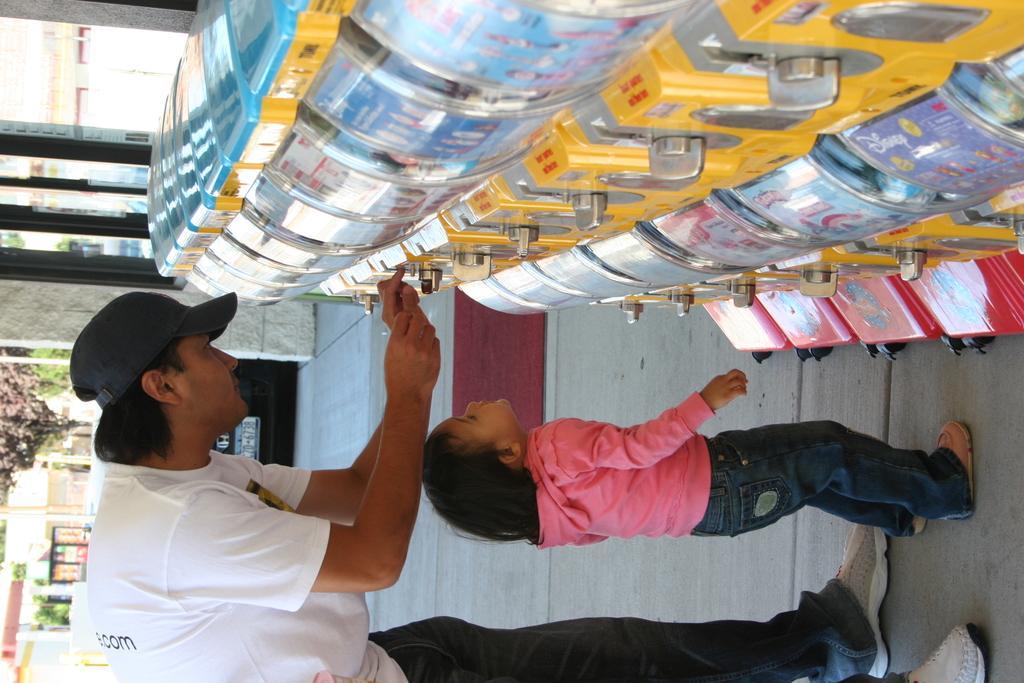How would you summarize this image in a sentence or two? In this picture i can see a man and a girl are standing. The man is wearing cap, t shirt, pant and shoes. On the right some objects. In the background i can see trees and other objects. 